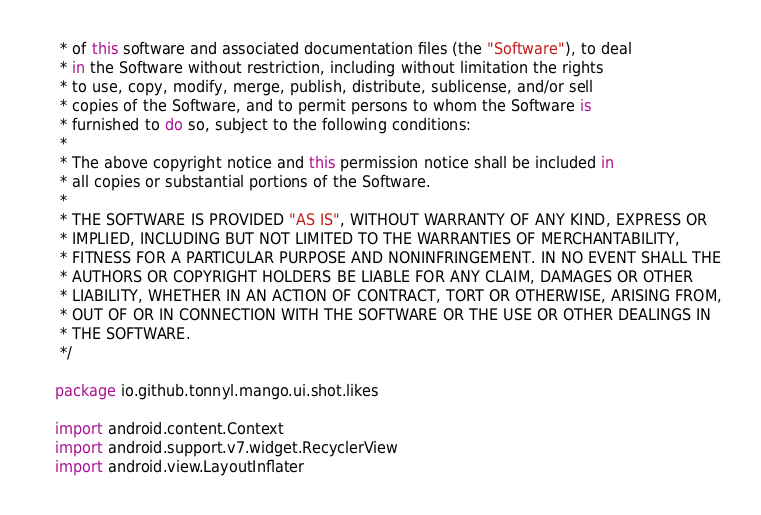<code> <loc_0><loc_0><loc_500><loc_500><_Kotlin_> * of this software and associated documentation files (the "Software"), to deal
 * in the Software without restriction, including without limitation the rights
 * to use, copy, modify, merge, publish, distribute, sublicense, and/or sell
 * copies of the Software, and to permit persons to whom the Software is
 * furnished to do so, subject to the following conditions:
 *
 * The above copyright notice and this permission notice shall be included in
 * all copies or substantial portions of the Software.
 *
 * THE SOFTWARE IS PROVIDED "AS IS", WITHOUT WARRANTY OF ANY KIND, EXPRESS OR
 * IMPLIED, INCLUDING BUT NOT LIMITED TO THE WARRANTIES OF MERCHANTABILITY,
 * FITNESS FOR A PARTICULAR PURPOSE AND NONINFRINGEMENT. IN NO EVENT SHALL THE
 * AUTHORS OR COPYRIGHT HOLDERS BE LIABLE FOR ANY CLAIM, DAMAGES OR OTHER
 * LIABILITY, WHETHER IN AN ACTION OF CONTRACT, TORT OR OTHERWISE, ARISING FROM,
 * OUT OF OR IN CONNECTION WITH THE SOFTWARE OR THE USE OR OTHER DEALINGS IN
 * THE SOFTWARE.
 */

package io.github.tonnyl.mango.ui.shot.likes

import android.content.Context
import android.support.v7.widget.RecyclerView
import android.view.LayoutInflater</code> 